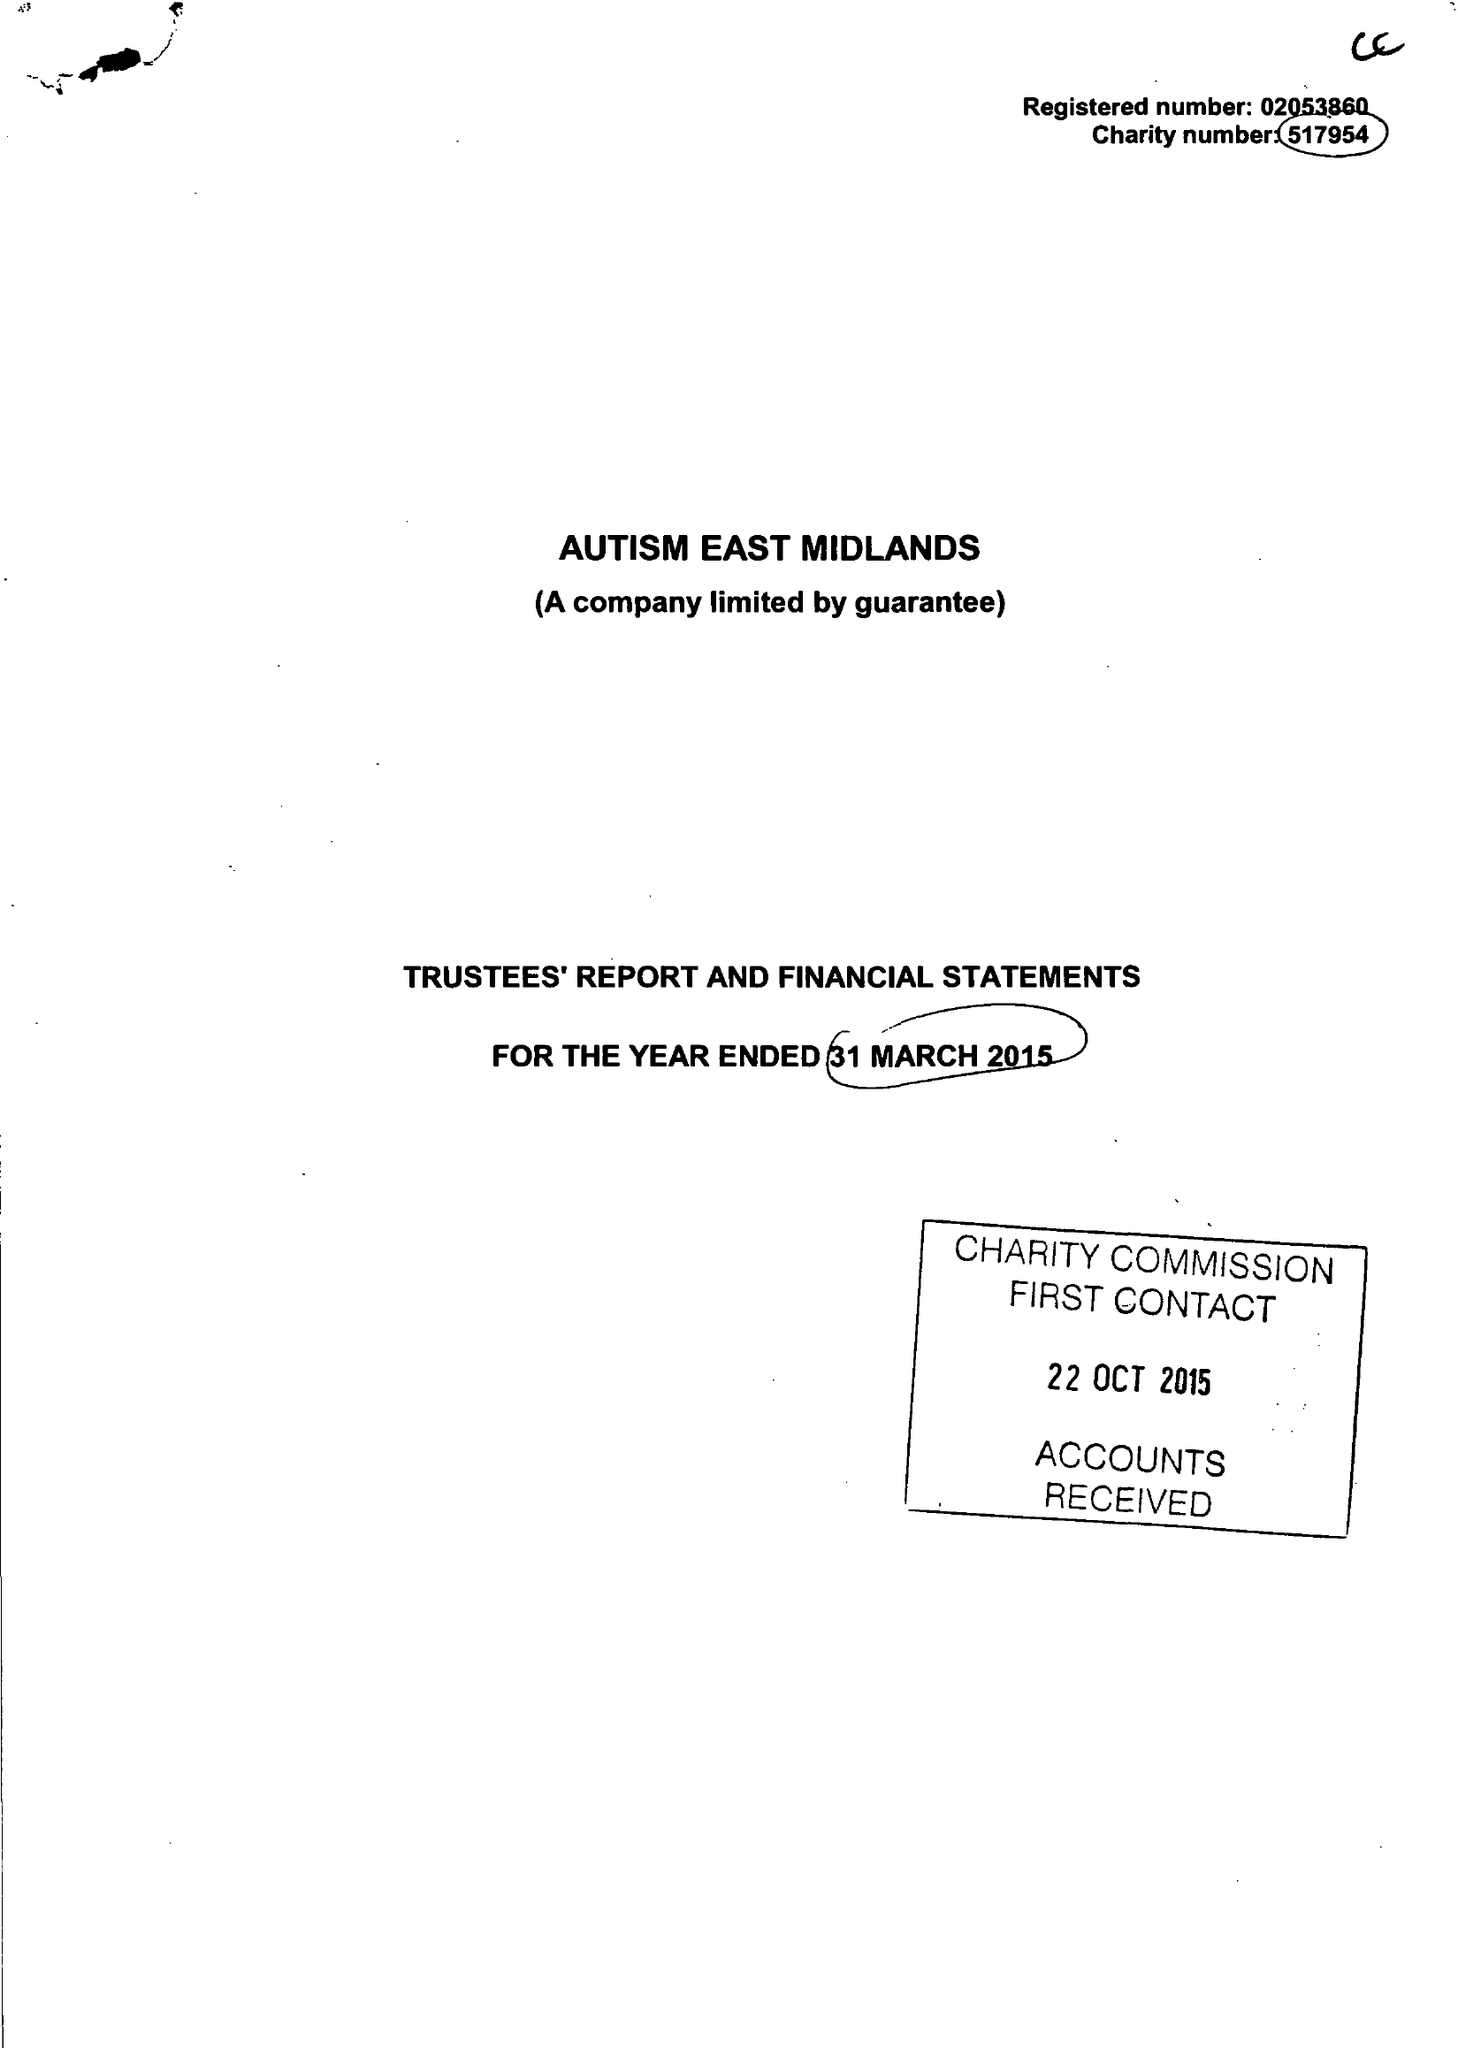What is the value for the income_annually_in_british_pounds?
Answer the question using a single word or phrase. 12095496.00 